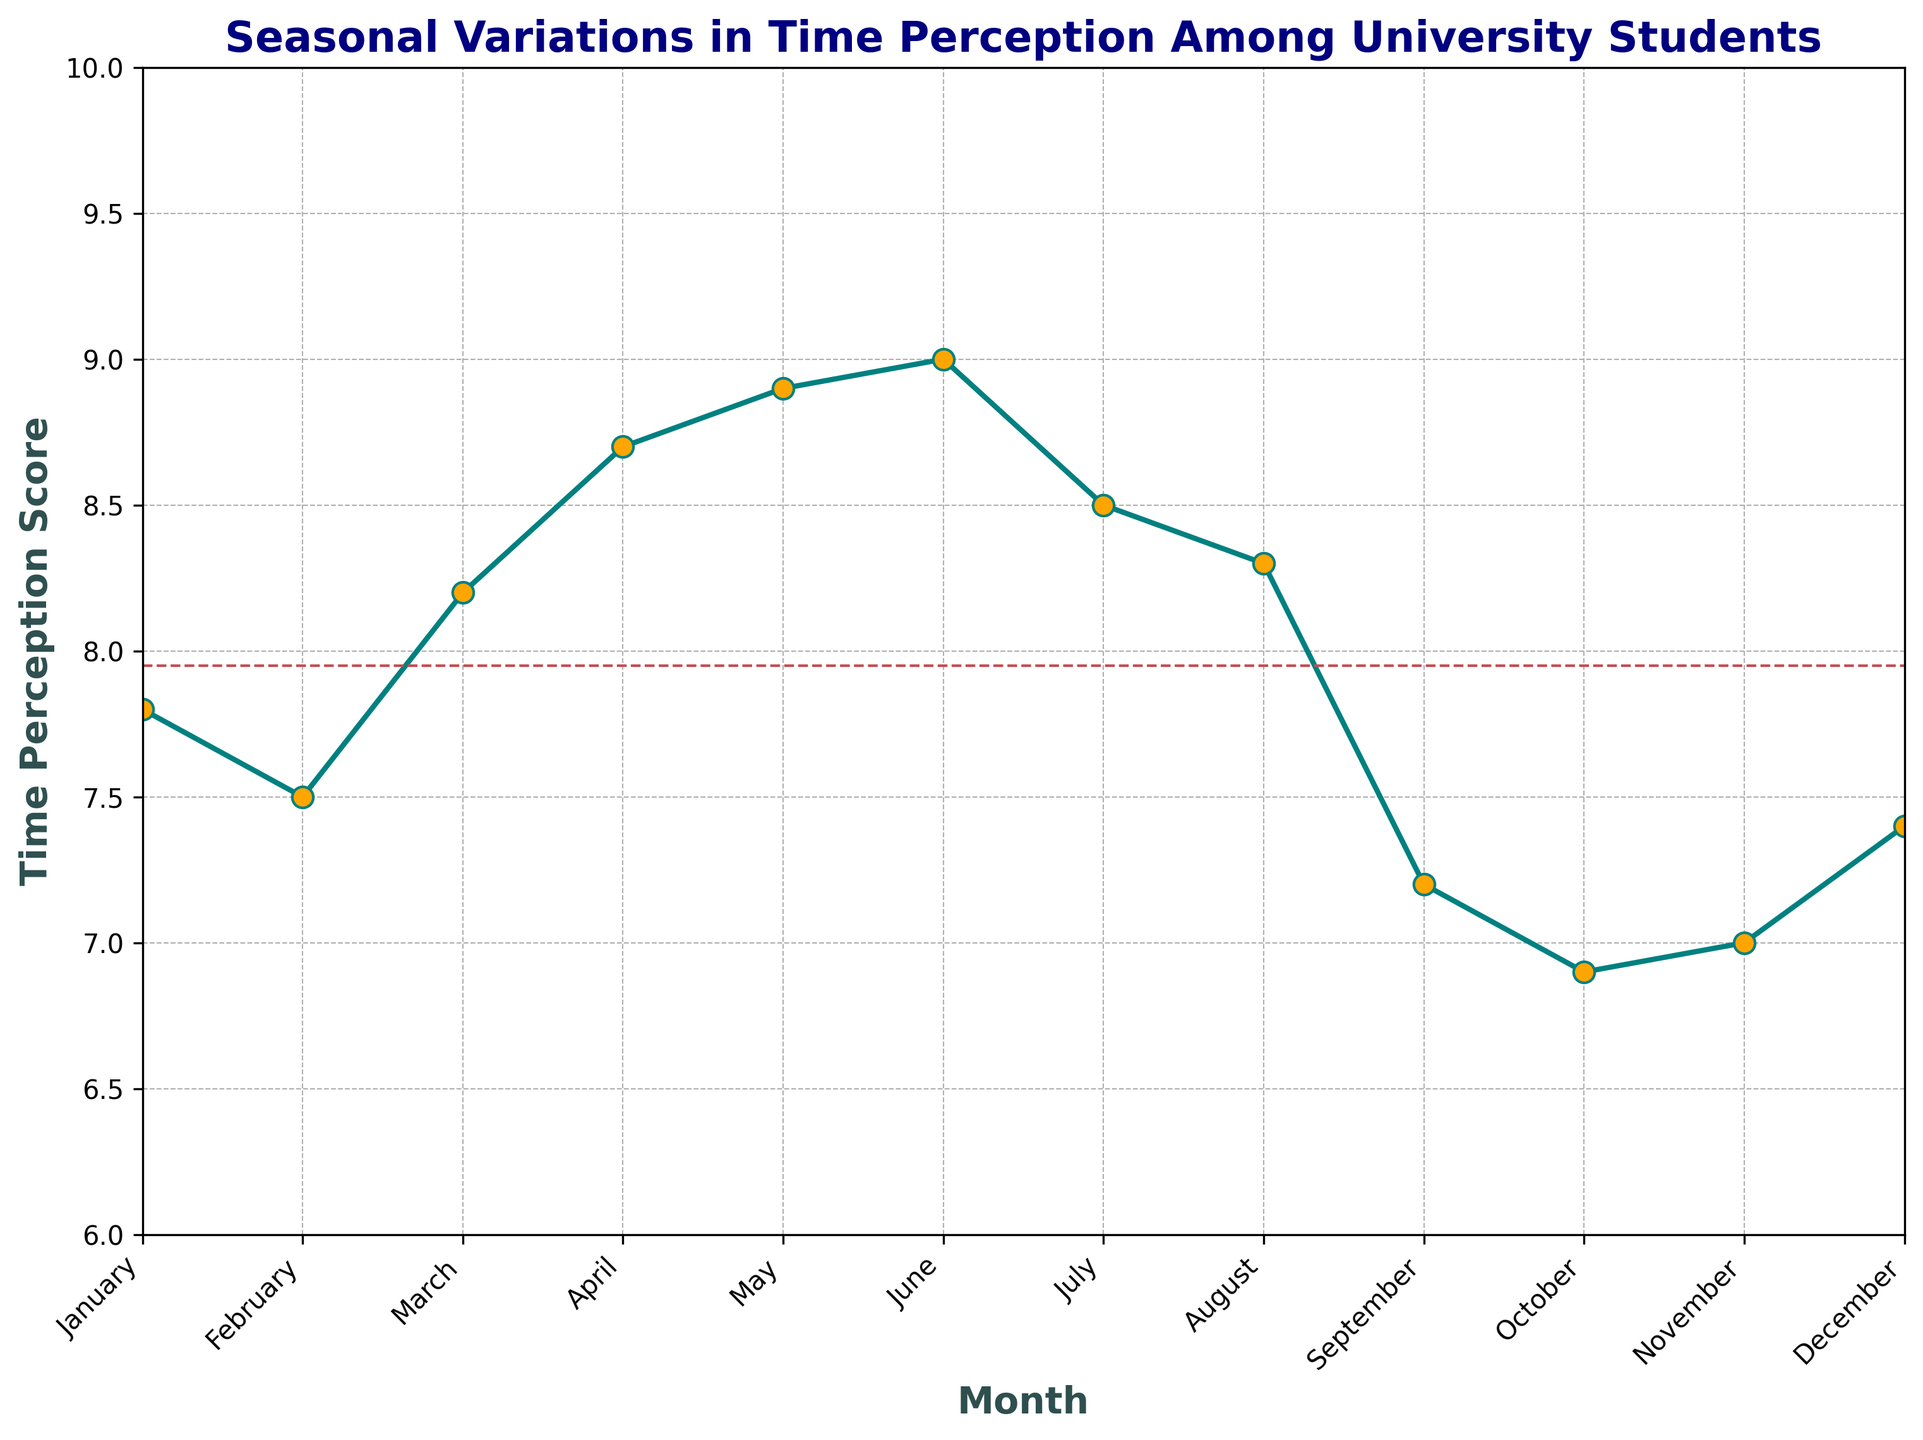what's the month with the highest time perception score? The figure shows a line chart with data points for each month. Identify the highest point on the line, which corresponds to the highest time perception score.
Answer: June which month has the lowest time perception score? Locate the lowest point on the line in the chart, which represents the month with the lowest time perception score.
Answer: October compare the time perception scores of January and December, which one is higher? Look at the line chart to find the time perception scores for January and December specifically. January's score is at 7.8, whereas December's score is at 7.4.
Answer: January what is the score trend from March to June? Inspect the line segments connecting March, April, May, and June. Notice that the line continuously moves upward, indicating an increasing trend.
Answer: Increasing what is the average time perception score over the year? Sum all the time perception scores from each month and divide by 12, the number of months. (7.8 + 7.5 + 8.2 + 8.7 + 8.9 + 9.0 + 8.5 + 8.3 + 7.2 + 6.9 + 7.0 + 7.4) / 12 = 8.006
Answer: 8.0 during which months does the time perception score exceed the average? First, find the average score as previously calculated (8.0). Then, identify the months where the score is higher than this value: March, April, May, June, July, August.
Answer: March, April, May, June, July, August how does the time perception score in September compare to that in August? Look at the data points for August (8.3) and September (7.2) on the line chart and compare them. The score in September is lower than in August.
Answer: Lower what is the difference in time perception scores between February and November? Identify the scores for February (7.5) and November (7.0) and calculate the difference. 7.5 - 7.0 = 0.5
Answer: 0.5 what is the average time perception score for the first half (January-June) and the second half (July-December) of the year? Calculate separately:
First half: (7.8 + 7.5 + 8.2 + 8.7 + 8.9 + 9.0) / 6 = 8.35
Second half: (8.5 + 8.3 + 7.2 + 6.9 + 7.0 + 7.4) / 6 = 7.55
Answer: First half: 8.35, Second half: 7.55 how many months have a time perception score below 7.5? Count the data points on the line chart that fall below the y-axis value of 7.5. These are October (6.9), September (7.2), and November (7.0).
Answer: 3 